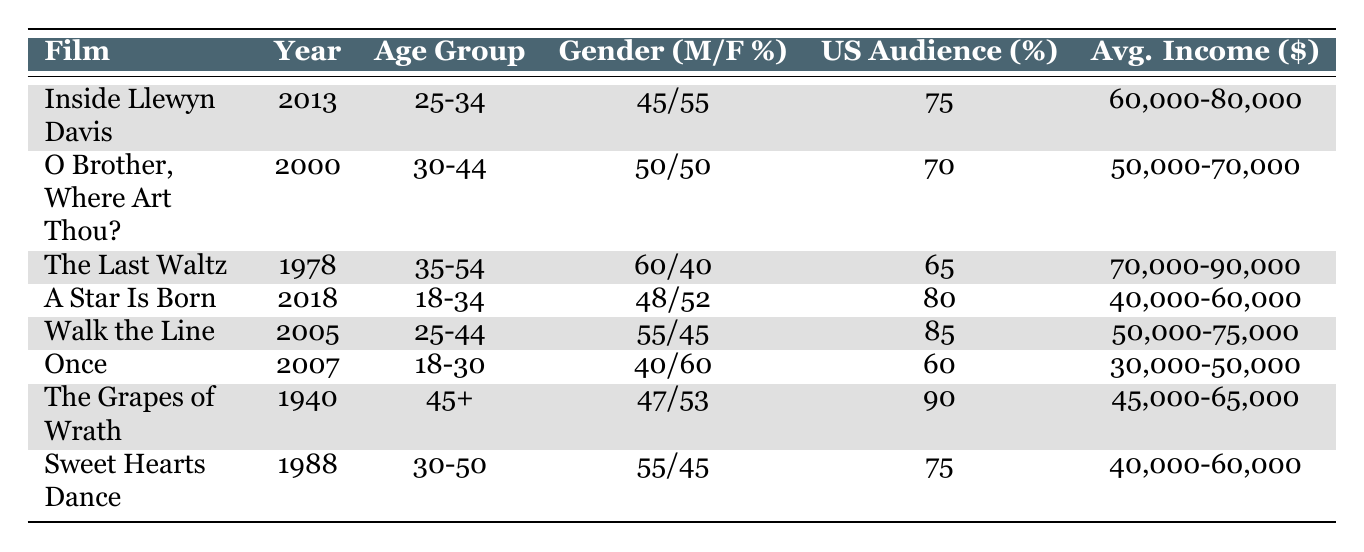What is the film with the highest percentage of US audience? By examining the US audience percentages in each row, "The Grapes of Wrath" has the highest percentage at 90%.
Answer: The Grapes of Wrath Which film features an audience age group of "18-34"? The table lists two films under the age group "18-34": "A Star Is Born" and "Once".
Answer: A Star Is Born, Once What is the average income range for "The Last Waltz"? Referring to the average income column for "The Last Waltz," it shows a range of 70,000-90,000.
Answer: 70,000-90,000 Which director has made the most films on this list? Looking at the directors, Joel and Ethan Coen and John have each directed two films; therefore, they are the most prolific directors in this list.
Answer: Joel and Ethan Coen, John Carney How many films have an audience age group of 25-34? The table shows two films: "Inside Llewyn Davis" and "A Star Is Born" belonging to this age group, thus totaling two films.
Answer: 2 Is there a film released in the 1980s with a US audience percentage under 80%? "Sweet Hearts Dance," released in 1988, has a US audience percentage of 75%, which is under 80%.
Answer: Yes What is the percentage of male audience for "Walk the Line"? Checking the gender distribution for "Walk the Line," it states 55% male audience.
Answer: 55% What is the average income range for films directed by Joel and Ethan Coen? The income ranges for their films ("Inside Llewyn Davis" and "O Brother, Where Art Thou?") are 60,000-80,000 and 50,000-70,000 respectively. The averages are calculated to be 55,000-75,000.
Answer: 55,000-75,000 Which film has the lowest average income range, and what is that range? The table shows that "Once" has the lowest average income range of 30,000-50,000.
Answer: 30,000-50,000 What is the difference in percentage of female audience between "The Last Waltz" and "O Brother, Where Art Thou?" "The Last Waltz" has 40% female and "O Brother, Where Art Thou?" has 50%. The difference is 50 - 40 = 10%.
Answer: 10% 